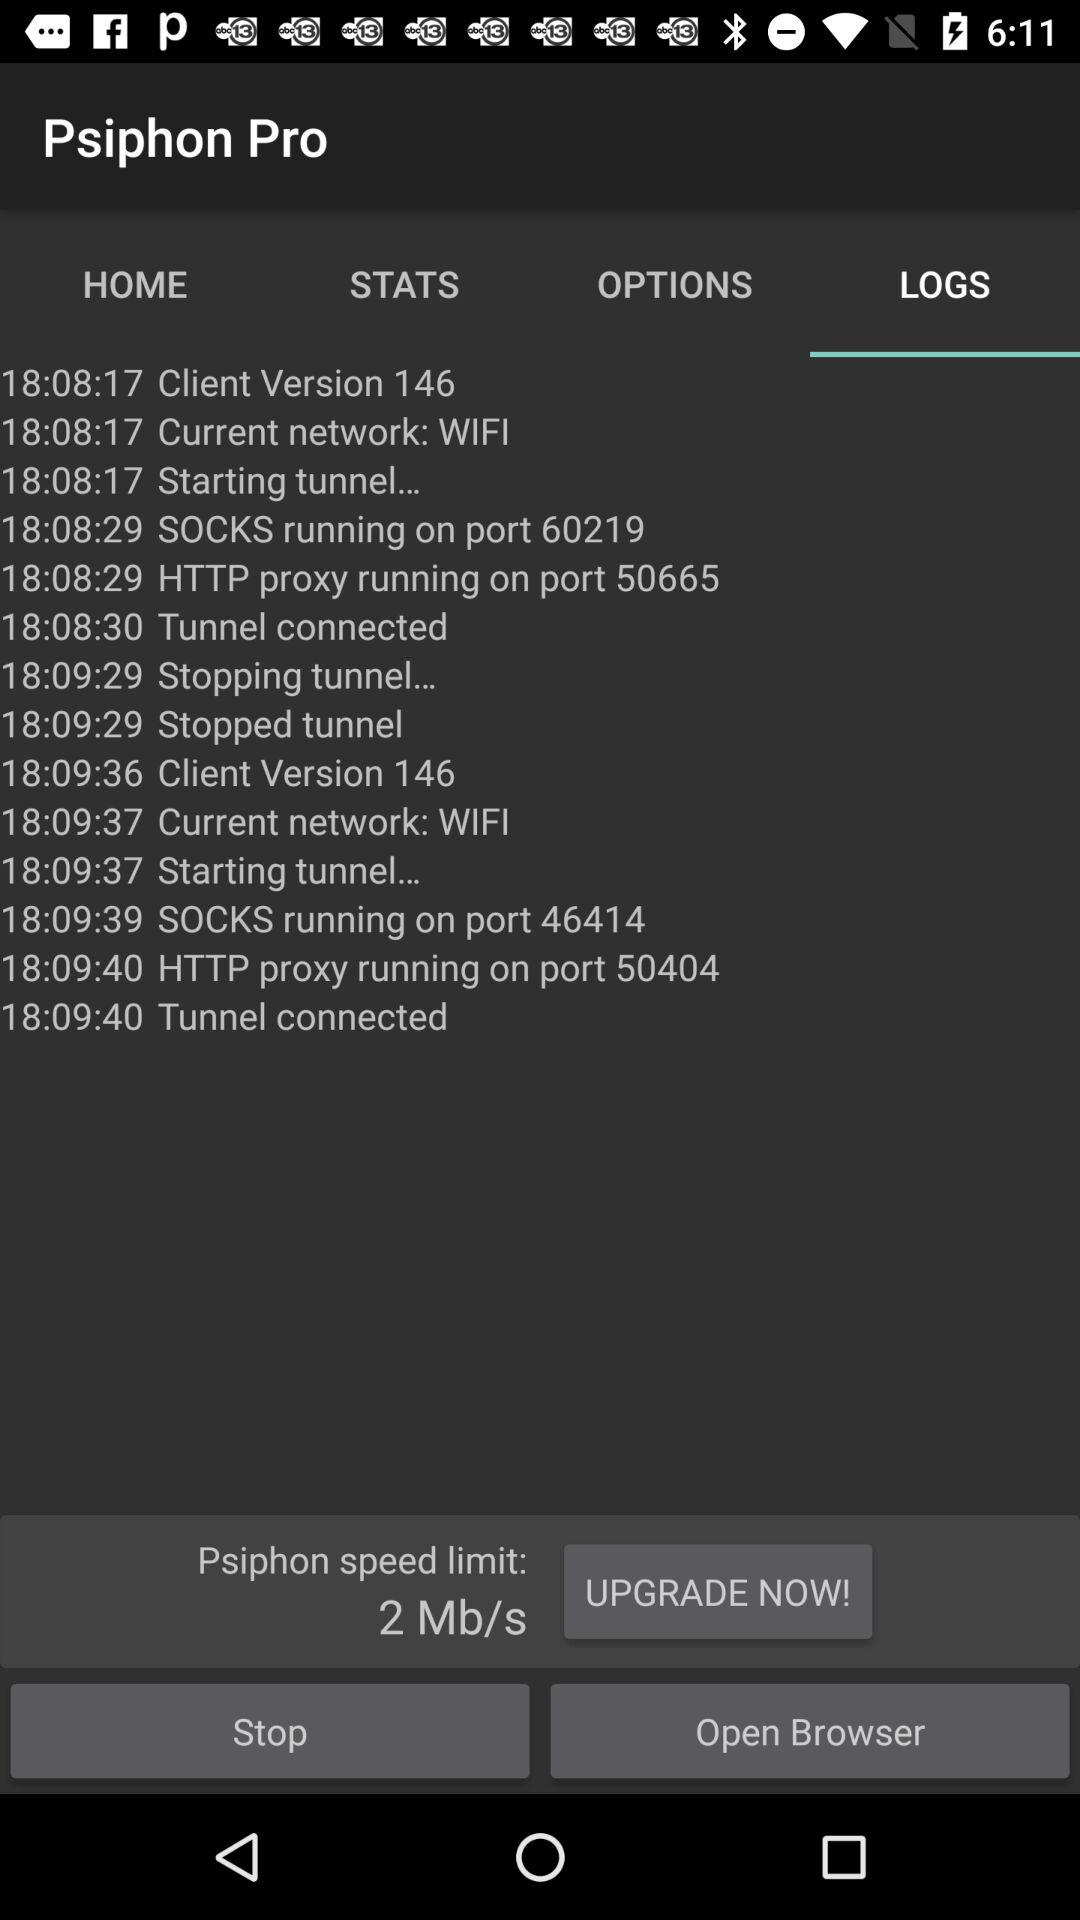What is the Psiphon speed limit? The Psiphon speed limit is 2 Mb/s. 